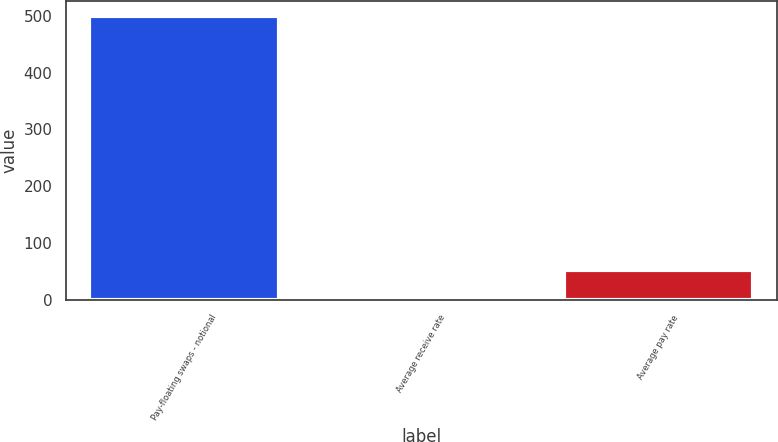Convert chart. <chart><loc_0><loc_0><loc_500><loc_500><bar_chart><fcel>Pay-floating swaps - notional<fcel>Average receive rate<fcel>Average pay rate<nl><fcel>500<fcel>2.2<fcel>51.98<nl></chart> 